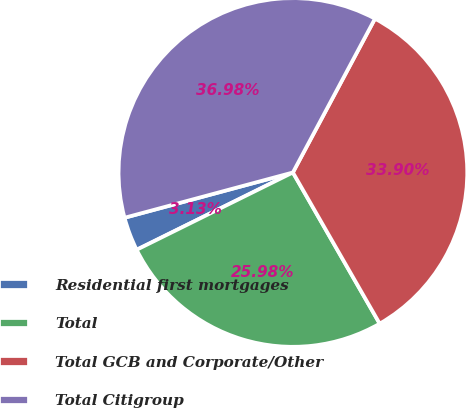<chart> <loc_0><loc_0><loc_500><loc_500><pie_chart><fcel>Residential first mortgages<fcel>Total<fcel>Total GCB and Corporate/Other<fcel>Total Citigroup<nl><fcel>3.13%<fcel>25.98%<fcel>33.9%<fcel>36.98%<nl></chart> 